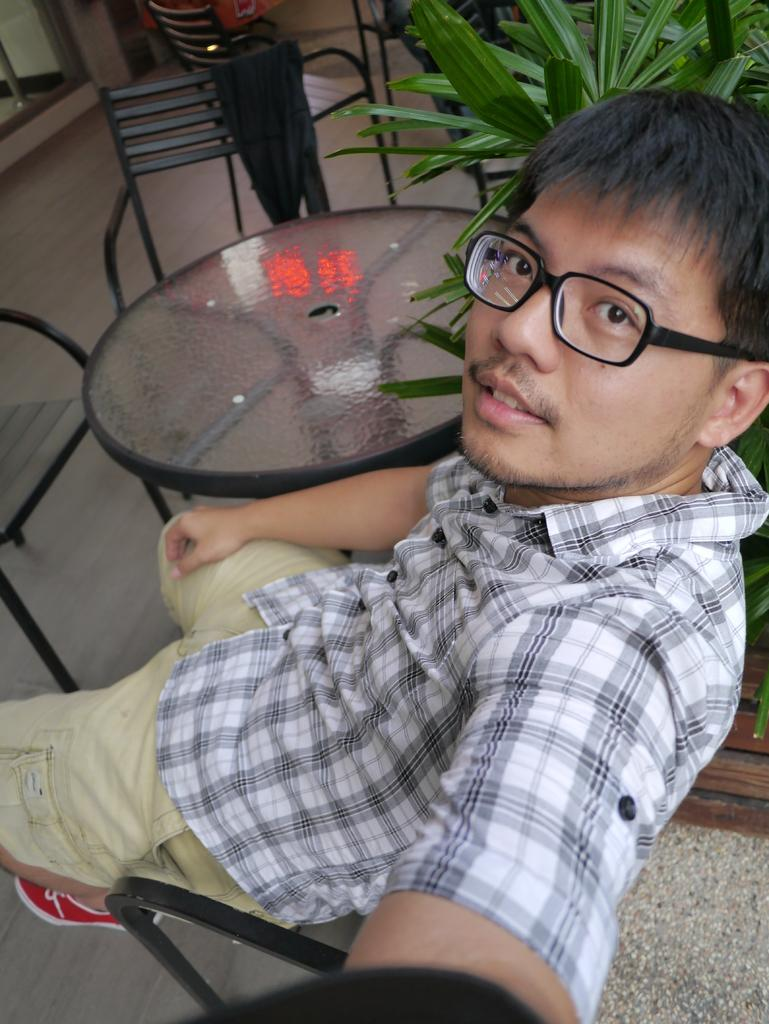What is the person in the image doing? There is a person sitting on a chair in the image. What can be seen behind the person? There are chairs behind a table in the image. What type of vegetation is visible in the image? There are plants in the right top area of the image. Where is the door located in the image? There is a door in the left top area of the image. Can you tell me how many loaves of bread are on the table in the image? There is no mention of loaves of bread in the image; the table has chairs behind it. 